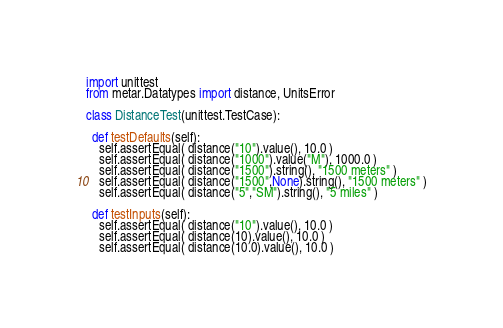<code> <loc_0><loc_0><loc_500><loc_500><_Python_>import unittest
from metar.Datatypes import distance, UnitsError

class DistanceTest(unittest.TestCase):
  
  def testDefaults(self):
    self.assertEqual( distance("10").value(), 10.0 )
    self.assertEqual( distance("1000").value("M"), 1000.0 )
    self.assertEqual( distance("1500").string(), "1500 meters" )
    self.assertEqual( distance("1500",None).string(), "1500 meters" )
    self.assertEqual( distance("5","SM").string(), "5 miles" )
  
  def testInputs(self):
    self.assertEqual( distance("10").value(), 10.0 )
    self.assertEqual( distance(10).value(), 10.0 )
    self.assertEqual( distance(10.0).value(), 10.0 )</code> 